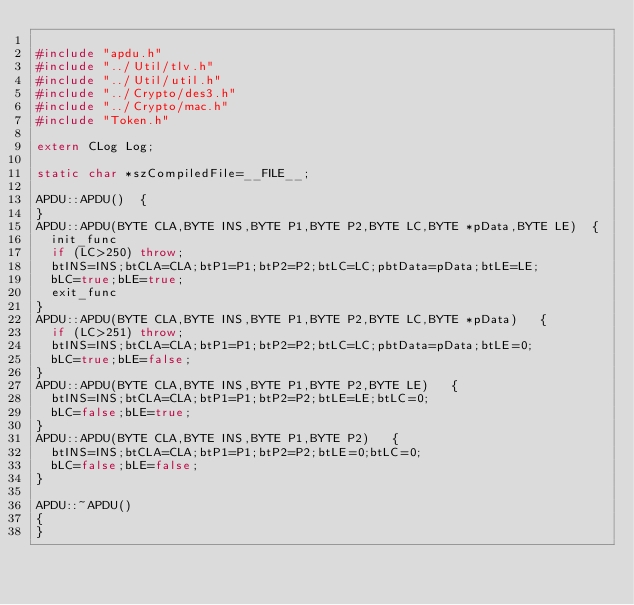<code> <loc_0><loc_0><loc_500><loc_500><_C++_>
#include "apdu.h"
#include "../Util/tlv.h"
#include "../Util/util.h"
#include "../Crypto/des3.h"
#include "../Crypto/mac.h"
#include "Token.h"

extern CLog Log;

static char *szCompiledFile=__FILE__;

APDU::APDU()  {
}
APDU::APDU(BYTE CLA,BYTE INS,BYTE P1,BYTE P2,BYTE LC,BYTE *pData,BYTE LE)  {
	init_func
	if (LC>250) throw;
	btINS=INS;btCLA=CLA;btP1=P1;btP2=P2;btLC=LC;pbtData=pData;btLE=LE;
	bLC=true;bLE=true;
	exit_func
}
APDU::APDU(BYTE CLA,BYTE INS,BYTE P1,BYTE P2,BYTE LC,BYTE *pData)   {
	if (LC>251) throw;
	btINS=INS;btCLA=CLA;btP1=P1;btP2=P2;btLC=LC;pbtData=pData;btLE=0;
	bLC=true;bLE=false;
}
APDU::APDU(BYTE CLA,BYTE INS,BYTE P1,BYTE P2,BYTE LE)   {
	btINS=INS;btCLA=CLA;btP1=P1;btP2=P2;btLE=LE;btLC=0;
	bLC=false;bLE=true;
}
APDU::APDU(BYTE CLA,BYTE INS,BYTE P1,BYTE P2)   {
	btINS=INS;btCLA=CLA;btP1=P1;btP2=P2;btLE=0;btLC=0;
	bLC=false;bLE=false;
}

APDU::~APDU()
{
}
</code> 